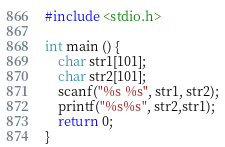Convert code to text. <code><loc_0><loc_0><loc_500><loc_500><_C++_>#include <stdio.h>

int main () {
  	char str1[101];
  	char str2[101];
  	scanf("%s %s", str1, str2);
  	printf("%s%s", str2,str1);
	return 0;
}</code> 